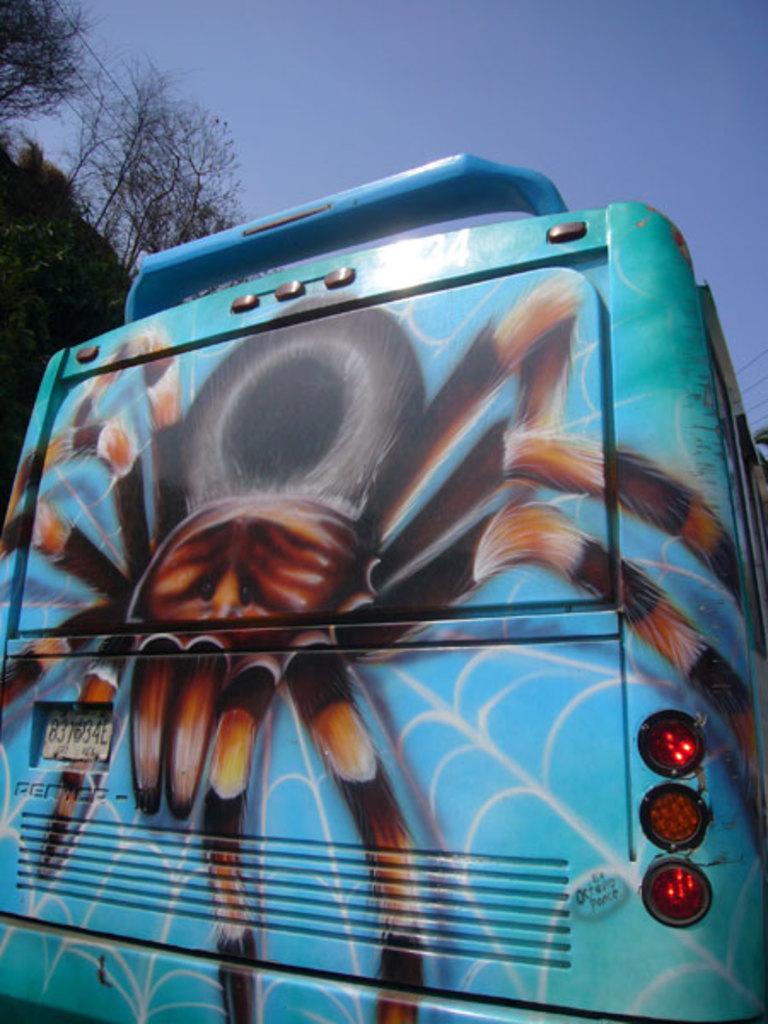Describe this image in one or two sentences. In this image we can see a vehicle which is truncated. On the vehicle we can see lights, number plate, and a picture of a spider. In the background there are trees and sky. 